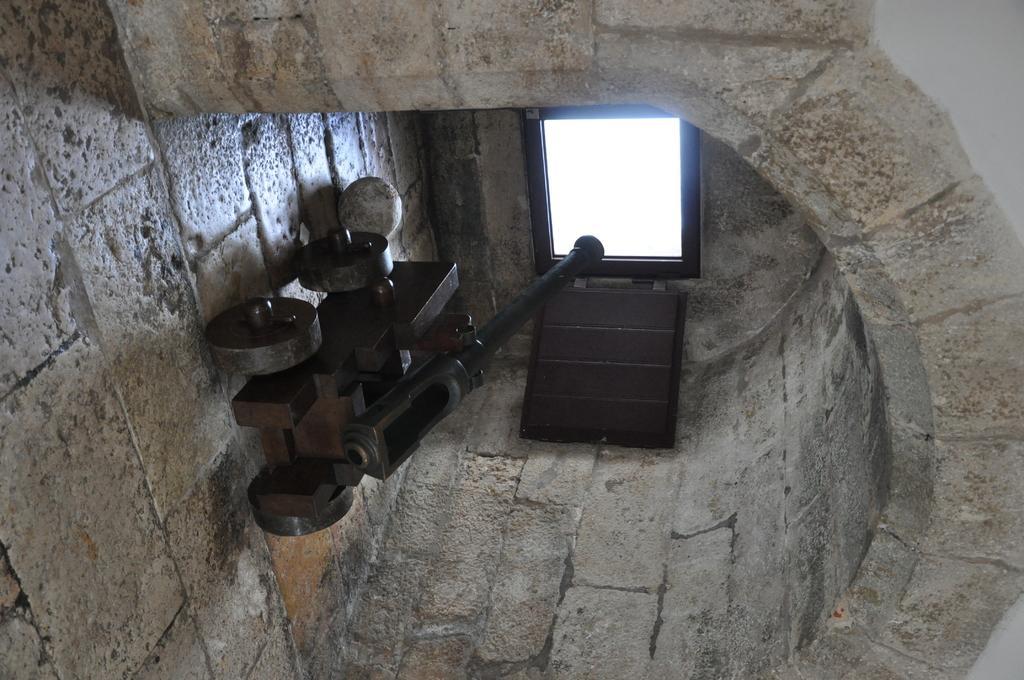Please provide a concise description of this image. In this image there is a cannon and ball on the floor under a curved roof in front of that there is a window in the middle of wall. 